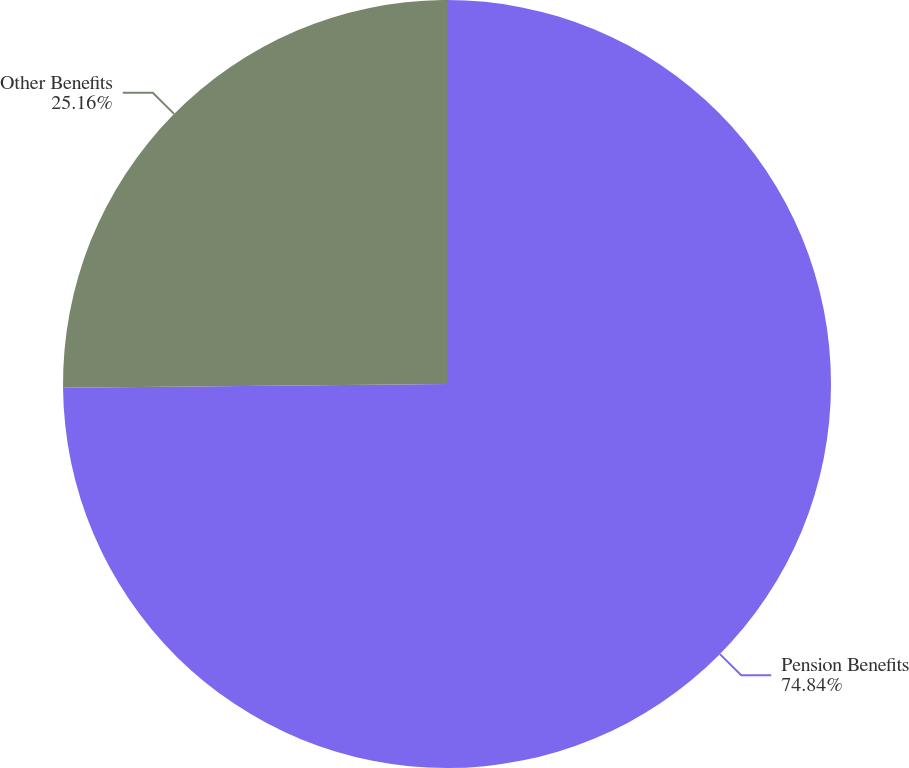<chart> <loc_0><loc_0><loc_500><loc_500><pie_chart><fcel>Pension Benefits<fcel>Other Benefits<nl><fcel>74.84%<fcel>25.16%<nl></chart> 